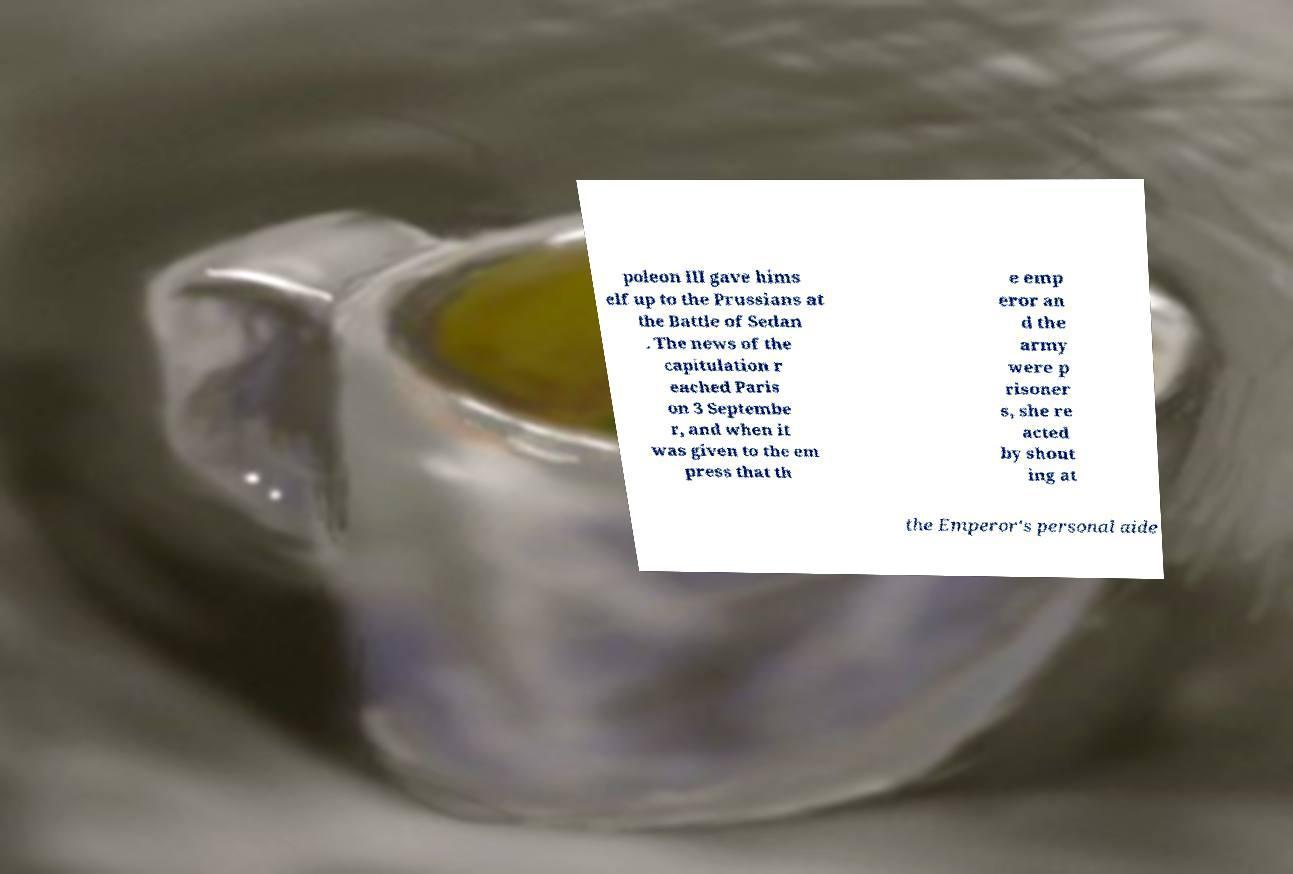There's text embedded in this image that I need extracted. Can you transcribe it verbatim? poleon III gave hims elf up to the Prussians at the Battle of Sedan . The news of the capitulation r eached Paris on 3 Septembe r, and when it was given to the em press that th e emp eror an d the army were p risoner s, she re acted by shout ing at the Emperor's personal aide 